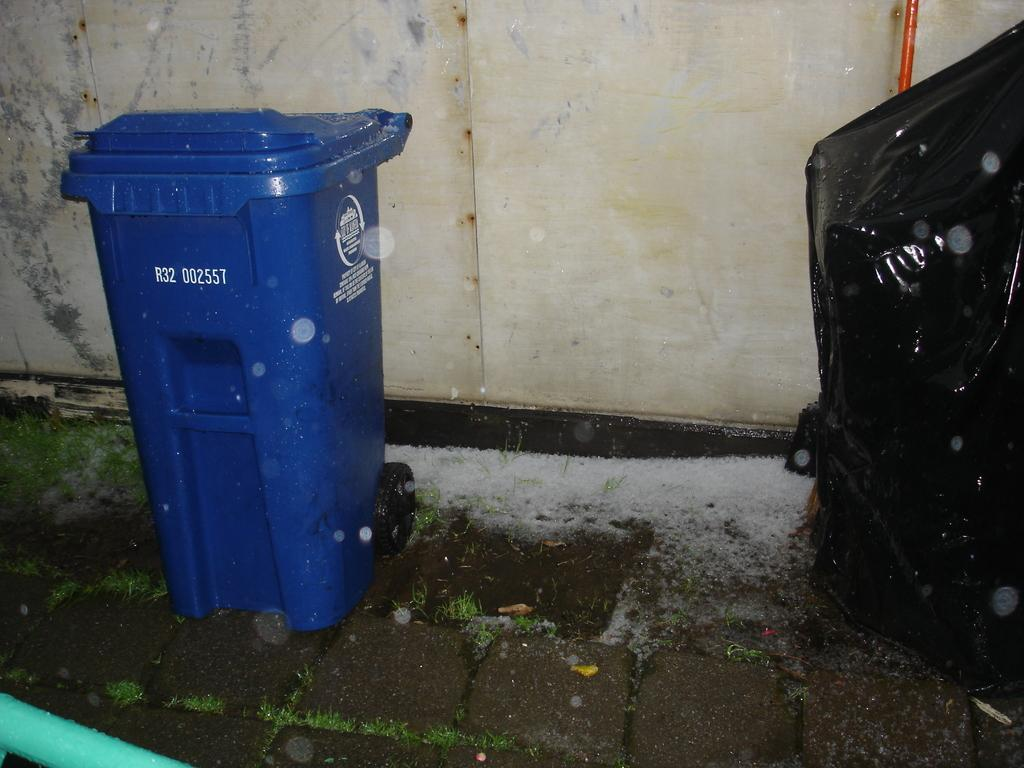<image>
Summarize the visual content of the image. a blue trash bin labeled R32 002557 sits on the street 